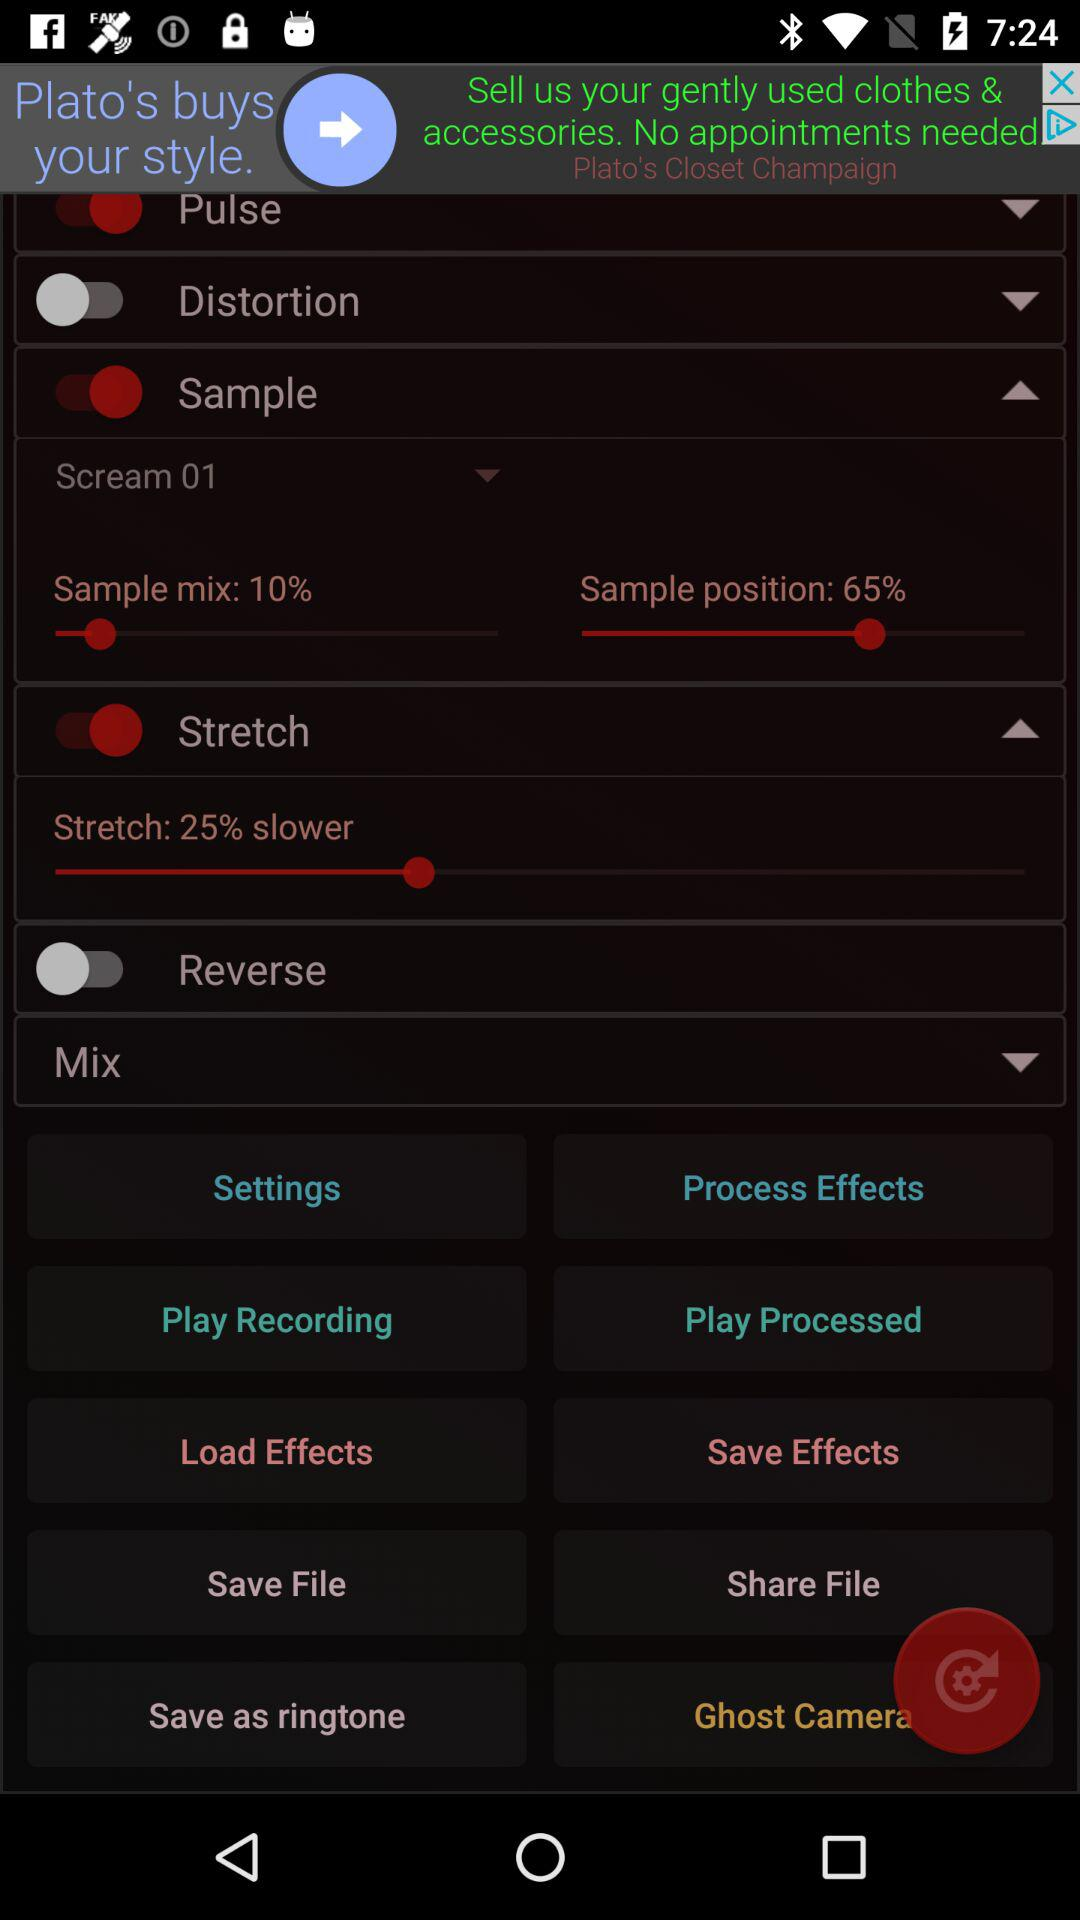What is the status of the distortion? The status is off. 